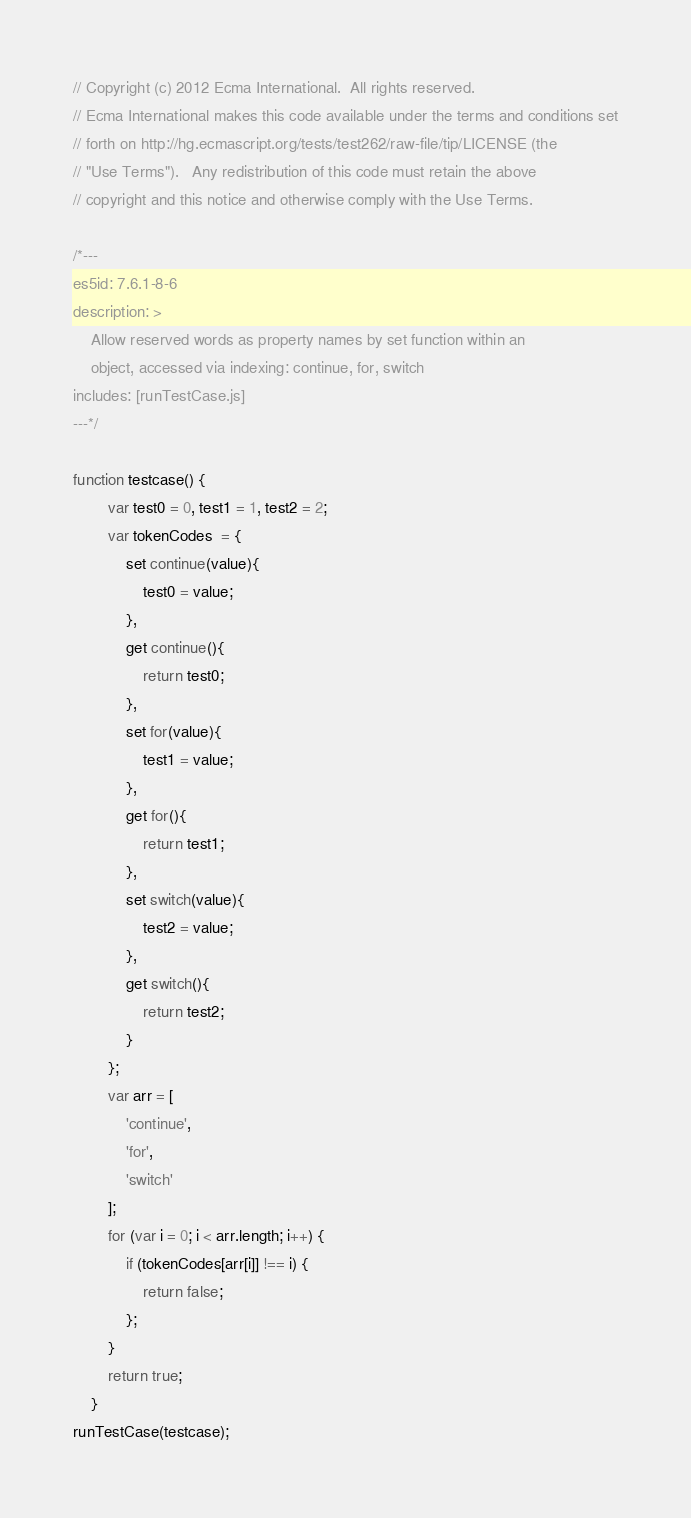<code> <loc_0><loc_0><loc_500><loc_500><_JavaScript_>// Copyright (c) 2012 Ecma International.  All rights reserved.
// Ecma International makes this code available under the terms and conditions set
// forth on http://hg.ecmascript.org/tests/test262/raw-file/tip/LICENSE (the
// "Use Terms").   Any redistribution of this code must retain the above
// copyright and this notice and otherwise comply with the Use Terms.

/*---
es5id: 7.6.1-8-6
description: >
    Allow reserved words as property names by set function within an
    object, accessed via indexing: continue, for, switch
includes: [runTestCase.js]
---*/

function testcase() {
        var test0 = 0, test1 = 1, test2 = 2;
        var tokenCodes  = {
            set continue(value){
                test0 = value;
            },
            get continue(){
                return test0;
            },
            set for(value){
                test1 = value;
            },
            get for(){
                return test1;
            },
            set switch(value){
                test2 = value;
            },
            get switch(){
                return test2;
            }
        }; 
        var arr = [
            'continue', 
            'for',
            'switch'
        ];
        for (var i = 0; i < arr.length; i++) {
            if (tokenCodes[arr[i]] !== i) {
                return false;
            };
        }
        return true;
    }
runTestCase(testcase);
</code> 